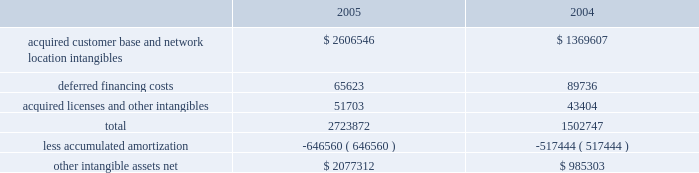American tower corporation and subsidiaries notes to consolidated financial statements 2014 ( continued ) the company has selected december 1 as the date to perform its annual impairment test .
In performing its 2005 and 2004 testing , the company completed an internal appraisal and estimated the fair value of the rental and management reporting unit that contains goodwill utilizing future discounted cash flows and market information .
Based on the appraisals performed , the company determined that goodwill in its rental and management segment was not impaired .
The company 2019s other intangible assets subject to amortization consist of the following as of december 31 , ( in thousands ) : .
The company amortizes its intangible assets over periods ranging from three to fifteen years .
Amortization of intangible assets for the years ended december 31 , 2005 and 2004 aggregated approximately $ 136.0 million and $ 97.8 million , respectively ( excluding amortization of deferred financing costs , which is included in interest expense ) .
The company expects to record amortization expense of approximately $ 183.6 million , $ 178.3 million , $ 174.4 million , $ 172.7 million and $ 170.3 million , for the years ended december 31 , 2006 , 2007 , 2008 , 2009 and 2010 , respectively .
These amounts are subject to changes in estimates until the preliminary allocation of the spectrasite purchase price is finalized .
Notes receivable in 2000 , the company loaned tv azteca , s.a .
De c.v .
( tv azteca ) , the owner of a major national television network in mexico , $ 119.8 million .
The loan , which initially bore interest at 12.87% ( 12.87 % ) , payable quarterly , was discounted by the company , as the fair value interest rate at the date of the loan was determined to be 14.25% ( 14.25 % ) .
The loan was amended effective january 1 , 2003 to increase the original interest rate to 13.11% ( 13.11 % ) .
As of december 31 , 2005 and 2004 , approximately $ 119.8 million undiscounted ( $ 108.2 million discounted ) under the loan was outstanding and included in notes receivable and other long-term assets in the accompanying consolidated balance sheets .
The term of the loan is seventy years ; however , the loan may be prepaid by tv azteca without penalty during the last fifty years of the agreement .
The discount on the loan is being amortized to interest income 2014tv azteca , net , using the effective interest method over the seventy-year term of the loan .
Simultaneous with the signing of the loan agreement , the company also entered into a seventy year economic rights agreement with tv azteca regarding space not used by tv azteca on approximately 190 of its broadcast towers .
In exchange for the issuance of the below market interest rate loan discussed above and the annual payment of $ 1.5 million to tv azteca ( under the economic rights agreement ) , the company has the right to market and lease the unused tower space on the broadcast towers ( the economic rights ) .
Tv azteca retains title to these towers and is responsible for their operation and maintenance .
The company is entitled to 100% ( 100 % ) of the revenues generated from leases with tenants on the unused space and is responsible for any incremental operating expenses associated with those tenants. .
Assuming that intangible asset will be sold , what will be the accumulated deprecation at the end of 2006 , in millions? 
Computations: ((646560 / 1000) + 183.6)
Answer: 830.16. 